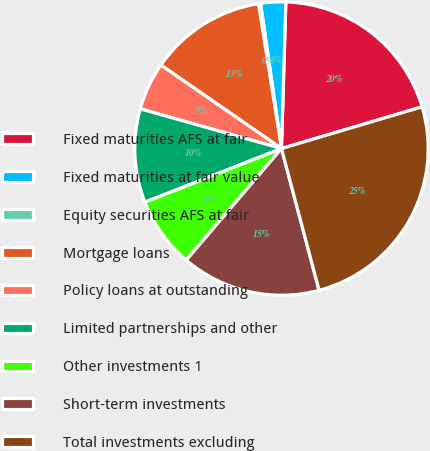Convert chart to OTSL. <chart><loc_0><loc_0><loc_500><loc_500><pie_chart><fcel>Fixed maturities AFS at fair<fcel>Fixed maturities at fair value<fcel>Equity securities AFS at fair<fcel>Mortgage loans<fcel>Policy loans at outstanding<fcel>Limited partnerships and other<fcel>Other investments 1<fcel>Short-term investments<fcel>Total investments excluding<nl><fcel>19.94%<fcel>2.75%<fcel>0.23%<fcel>12.85%<fcel>5.28%<fcel>10.32%<fcel>7.8%<fcel>15.37%<fcel>25.46%<nl></chart> 